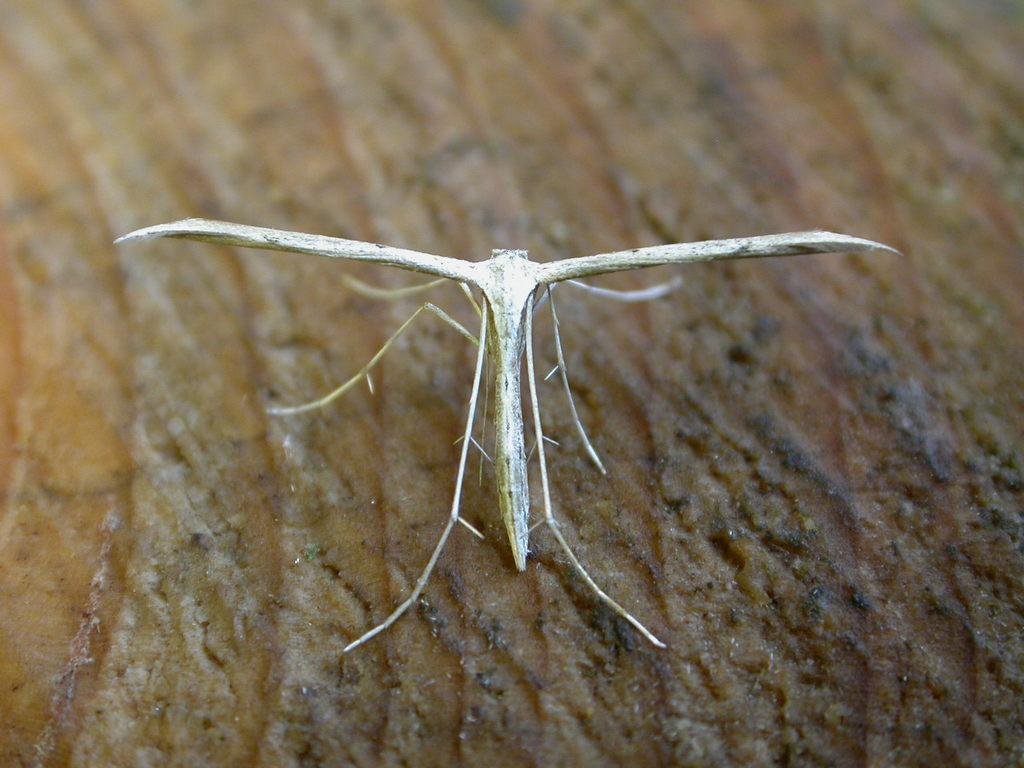What type of creature can be seen in the image? There is an insect in the image. Where is the insect located in the image? The insect is on an object. What type of mint is being weighed on the scale in the image? There is no mint or scale present in the image; it only features an insect on an object. 